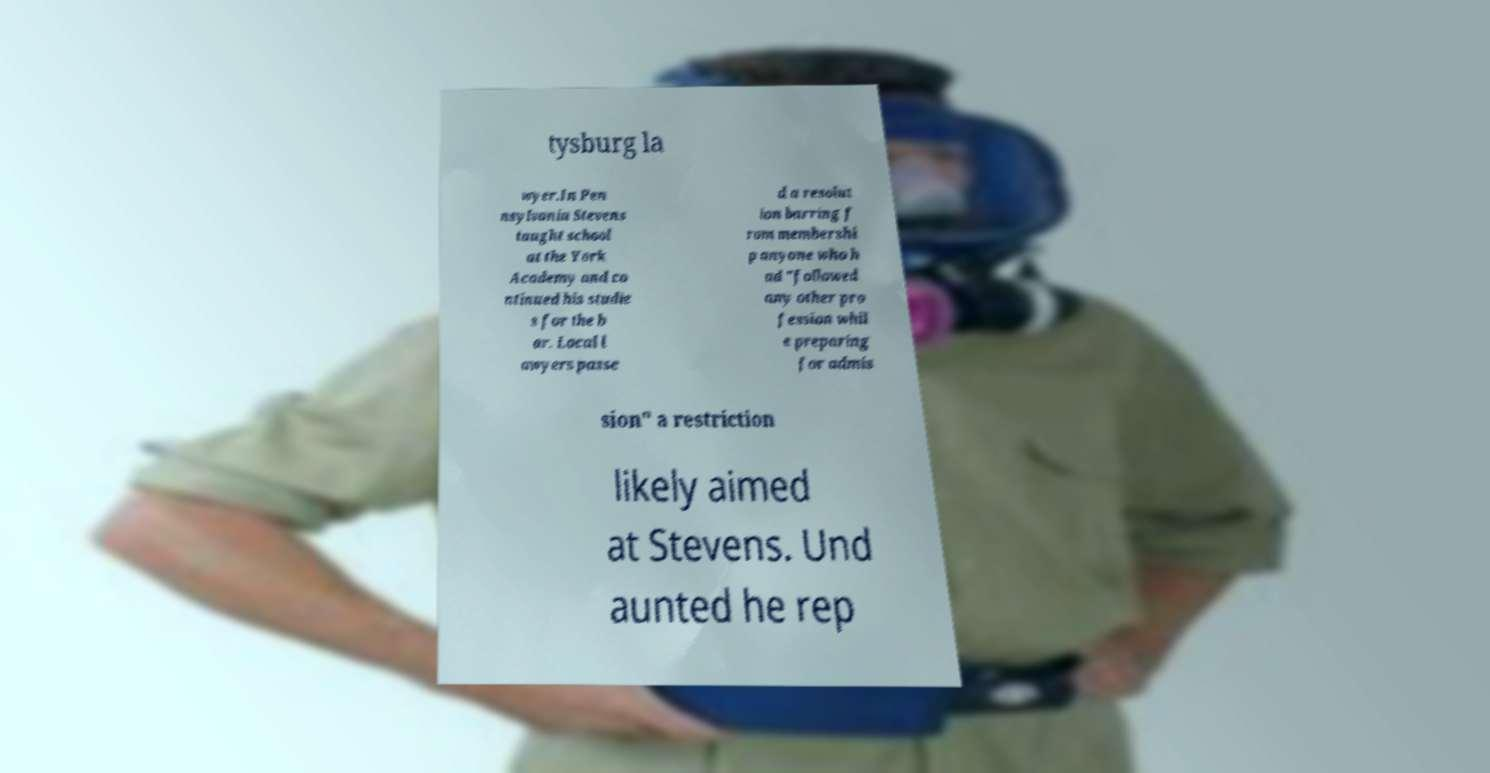Could you extract and type out the text from this image? tysburg la wyer.In Pen nsylvania Stevens taught school at the York Academy and co ntinued his studie s for the b ar. Local l awyers passe d a resolut ion barring f rom membershi p anyone who h ad "followed any other pro fession whil e preparing for admis sion" a restriction likely aimed at Stevens. Und aunted he rep 